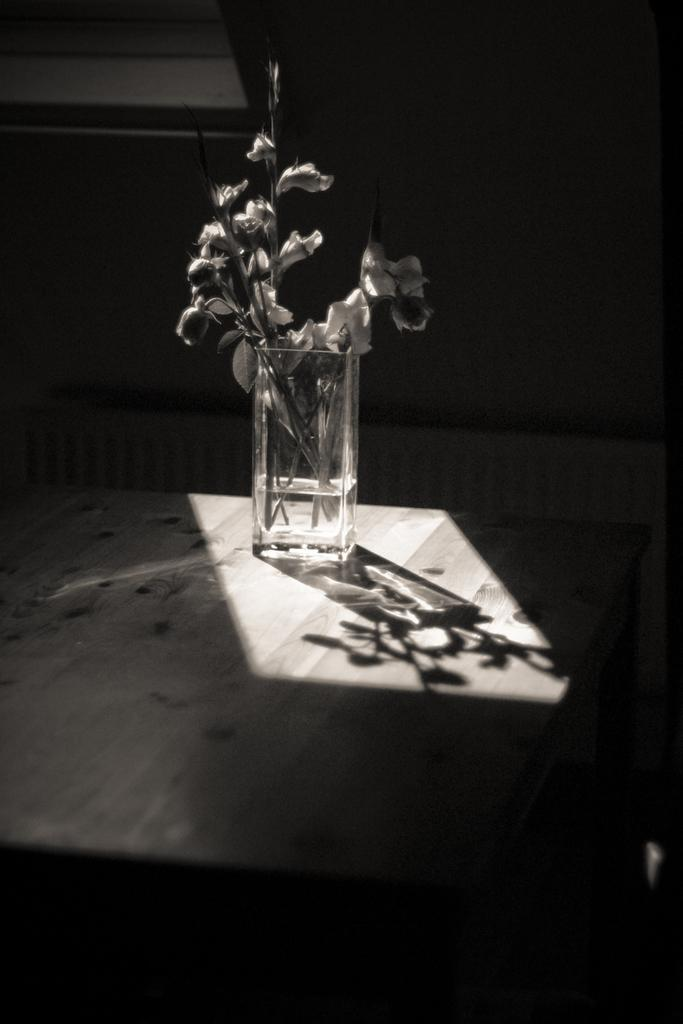What is inside the glass that is visible in the image? There is a glass filled with water in the image, and there are flowers in the glass. Where is the glass located in the image? The glass is on a table in the image. How does the bread jump in the image? There is no bread present in the image, so it cannot jump. 